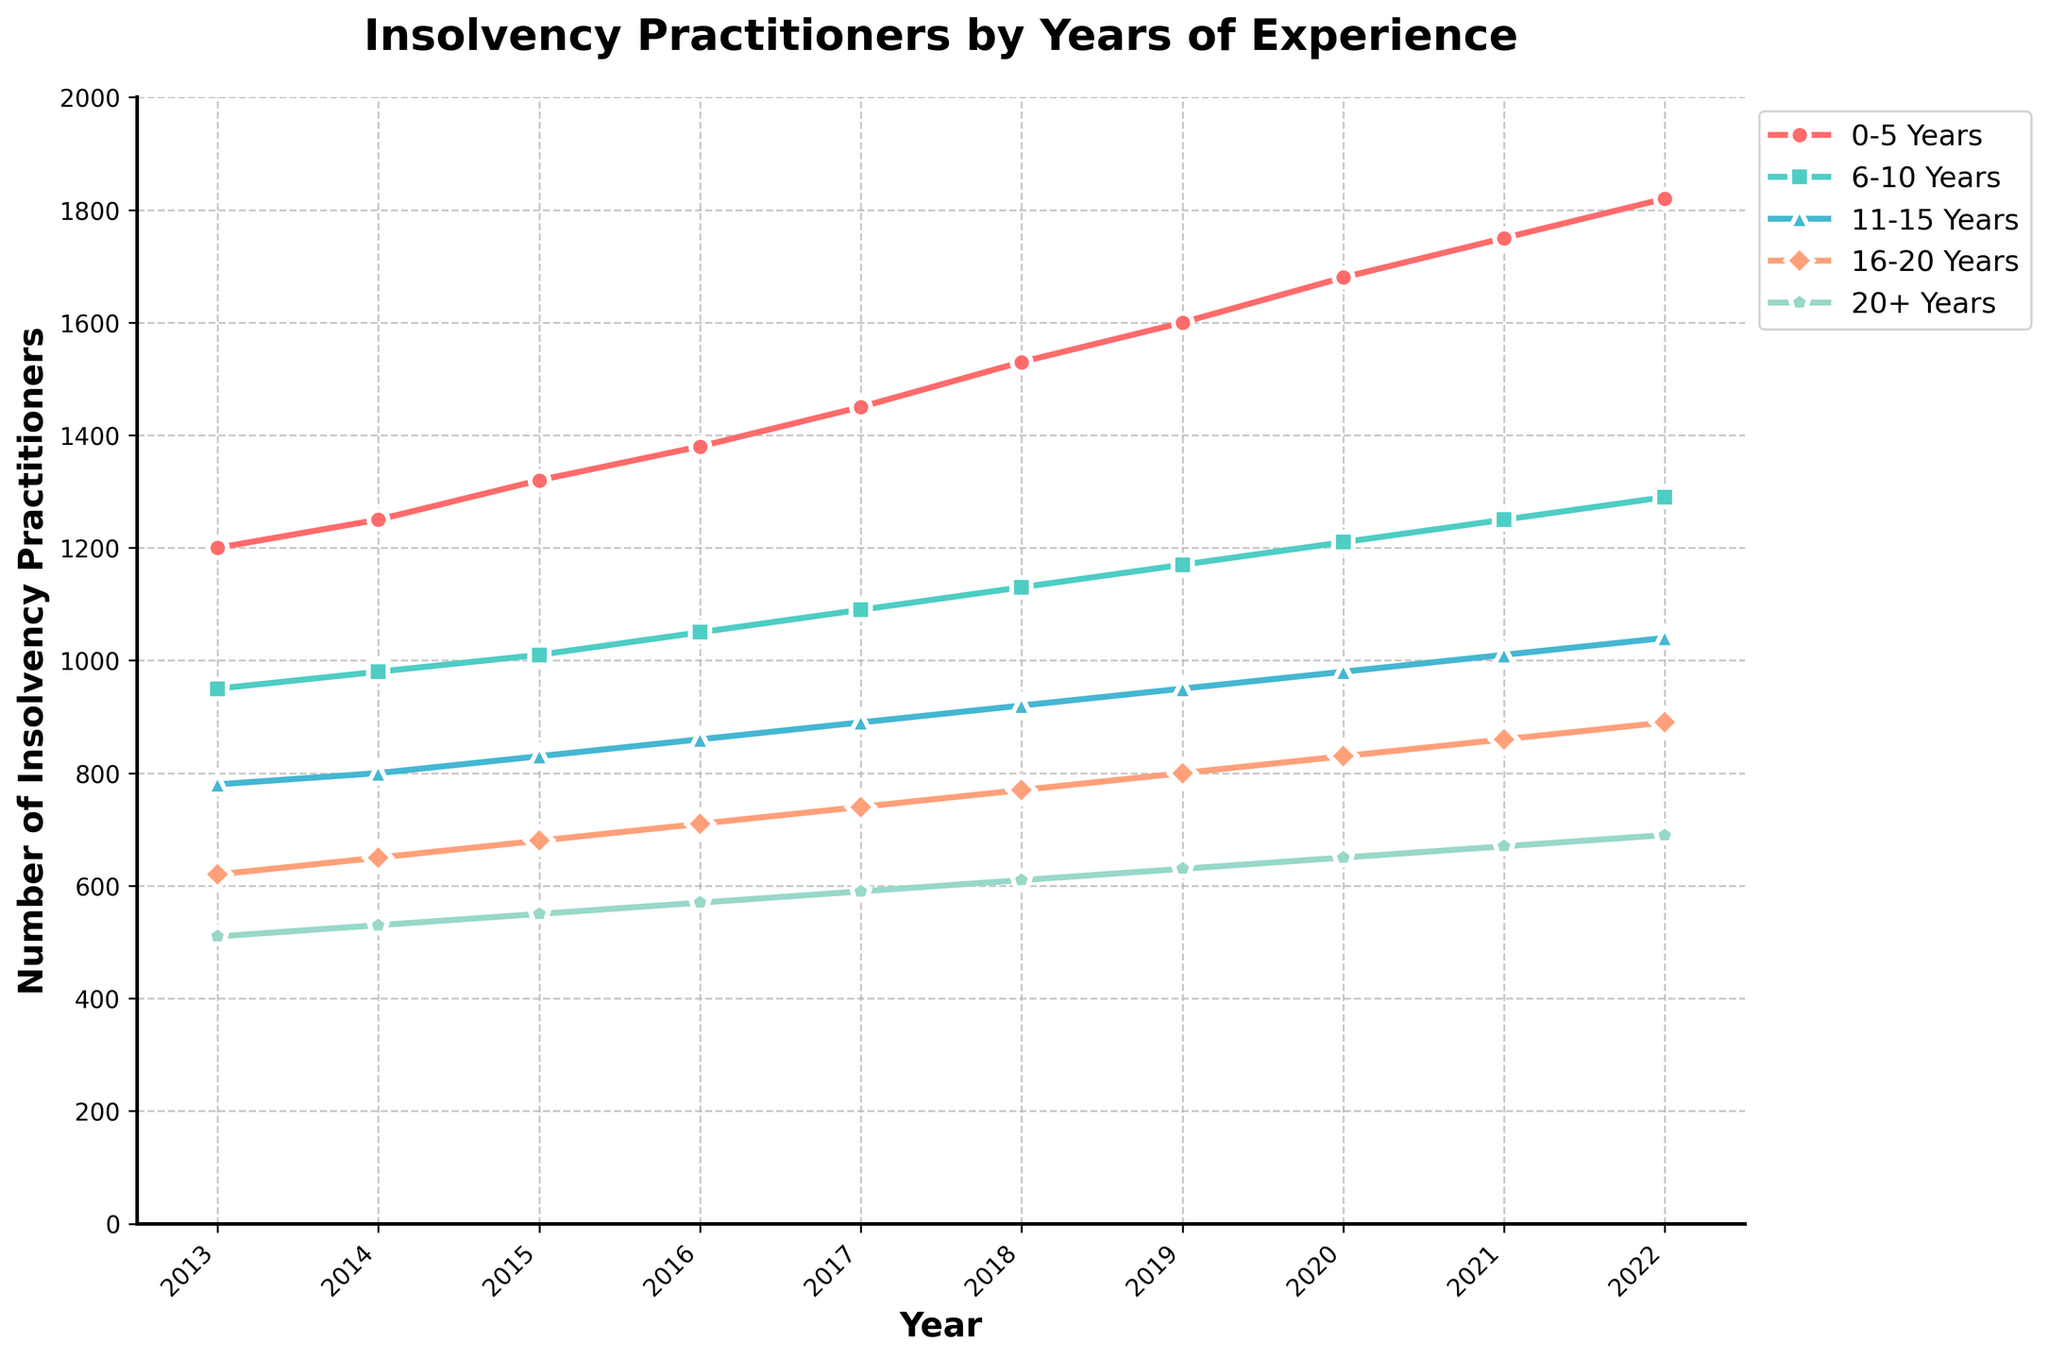Which year had the highest number of insolvency practitioners in the '0-5 Years' category? Look at the trend line for the '0-5 Years' category and identify the peak value, which occurs in the year 2022.
Answer: 2022 What is the overall trend of insolvency practitioners with '20+ Years' of experience from 2013 to 2022? Observe the trend line for the '20+ Years' category, which shows a consistent increase in the number of practitioners from 2013 to 2022.
Answer: Increasing How does the number of '11-15 Years' experience insolvency practitioners in 2016 compare to that in 2020? Compare the values of 2016 and 2020 for the '11-15 Years' category, which are 860 and 980, respectively. Calculate the difference: 980 - 860 = 120.
Answer: Increased by 120 Which experience category had the smallest change in the number of practitioners from 2013 to 2022? Calculate the difference between 2013 and 2022 for each category, then find the one with the smallest change. '20+ Years' category: 690 - 510 = 180; this has the smallest change.
Answer: 20+ Years What is the combined number of insolvency practitioners with '6-10 Years' and '16-20 Years' of experience in 2018? Add the values for '6-10 Years' and '16-20 Years' categories in 2018: 1130 + 770 = 1900.
Answer: 1900 Which category saw the largest increase in practitioners from 2013 to 2022? Calculate the increase for each category from 2013 to 2022 and compare them. '0-5 Years' category increased the most: 1820 - 1200 = 620.
Answer: 0-5 Years In which year did insolvency practitioners with '16-20 Years' of experience surpass 800 for the first time? Find the year when the '16-20 Years' category first exceeds 800 by checking each year's value. It happened in 2020.
Answer: 2020 How do the numbers of '0-5 Years' and '20+ Years' experience practitioners in 2015 compare? Look at the values for the '0-5 Years' and '20+ Years' categories in 2015, which are 1320 and 550, respectively.
Answer: 0-5 Years is higher What is the average number of insolvency practitioners with '6-10 Years' of experience over the given period? Sum the values for '6-10 Years' from 2013 to 2022 and divide by the number of years (10). Calculation: (950 + 980 + 1010 + 1050 + 1090 + 1130 + 1170 + 1210 + 1250 + 1290) / 10 = 1113.
Answer: 1113 Which experience category shows the most consistent increase over the years? Examine the trend lines for each category and identify the one with the most linear, consistent increase. '0-5 Years' shows the most consistent increase.
Answer: 0-5 Years 